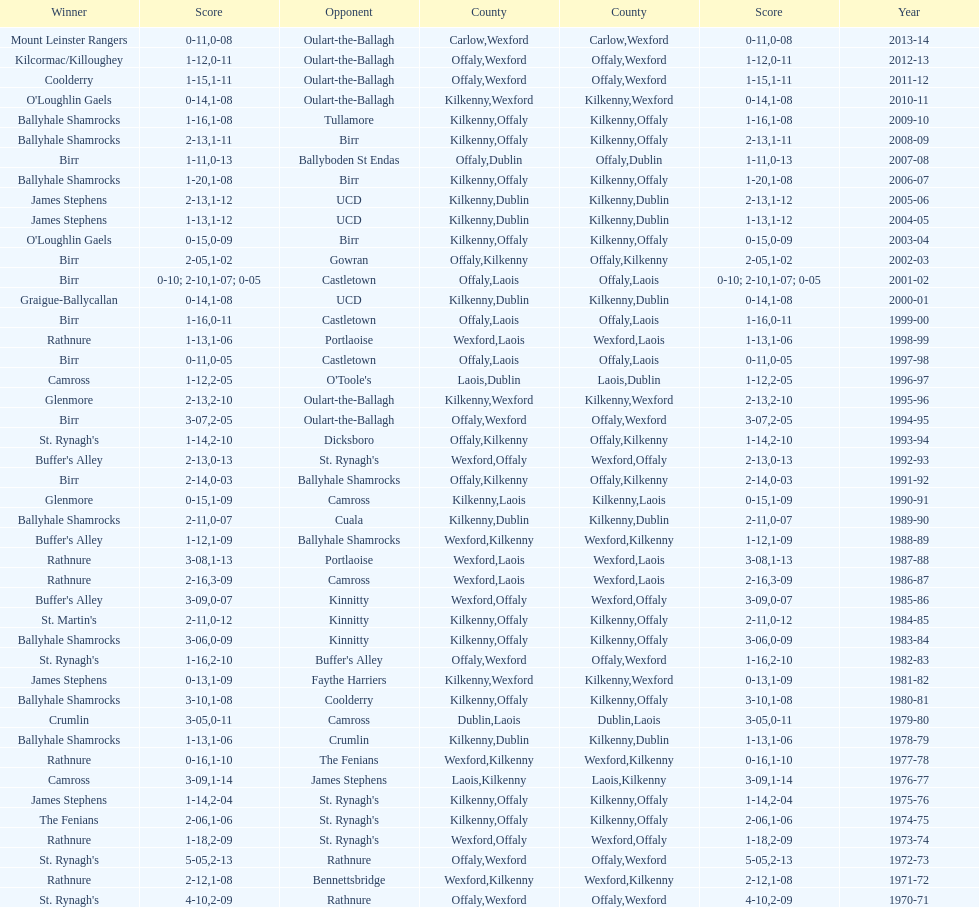Which country had the most wins? Kilkenny. 